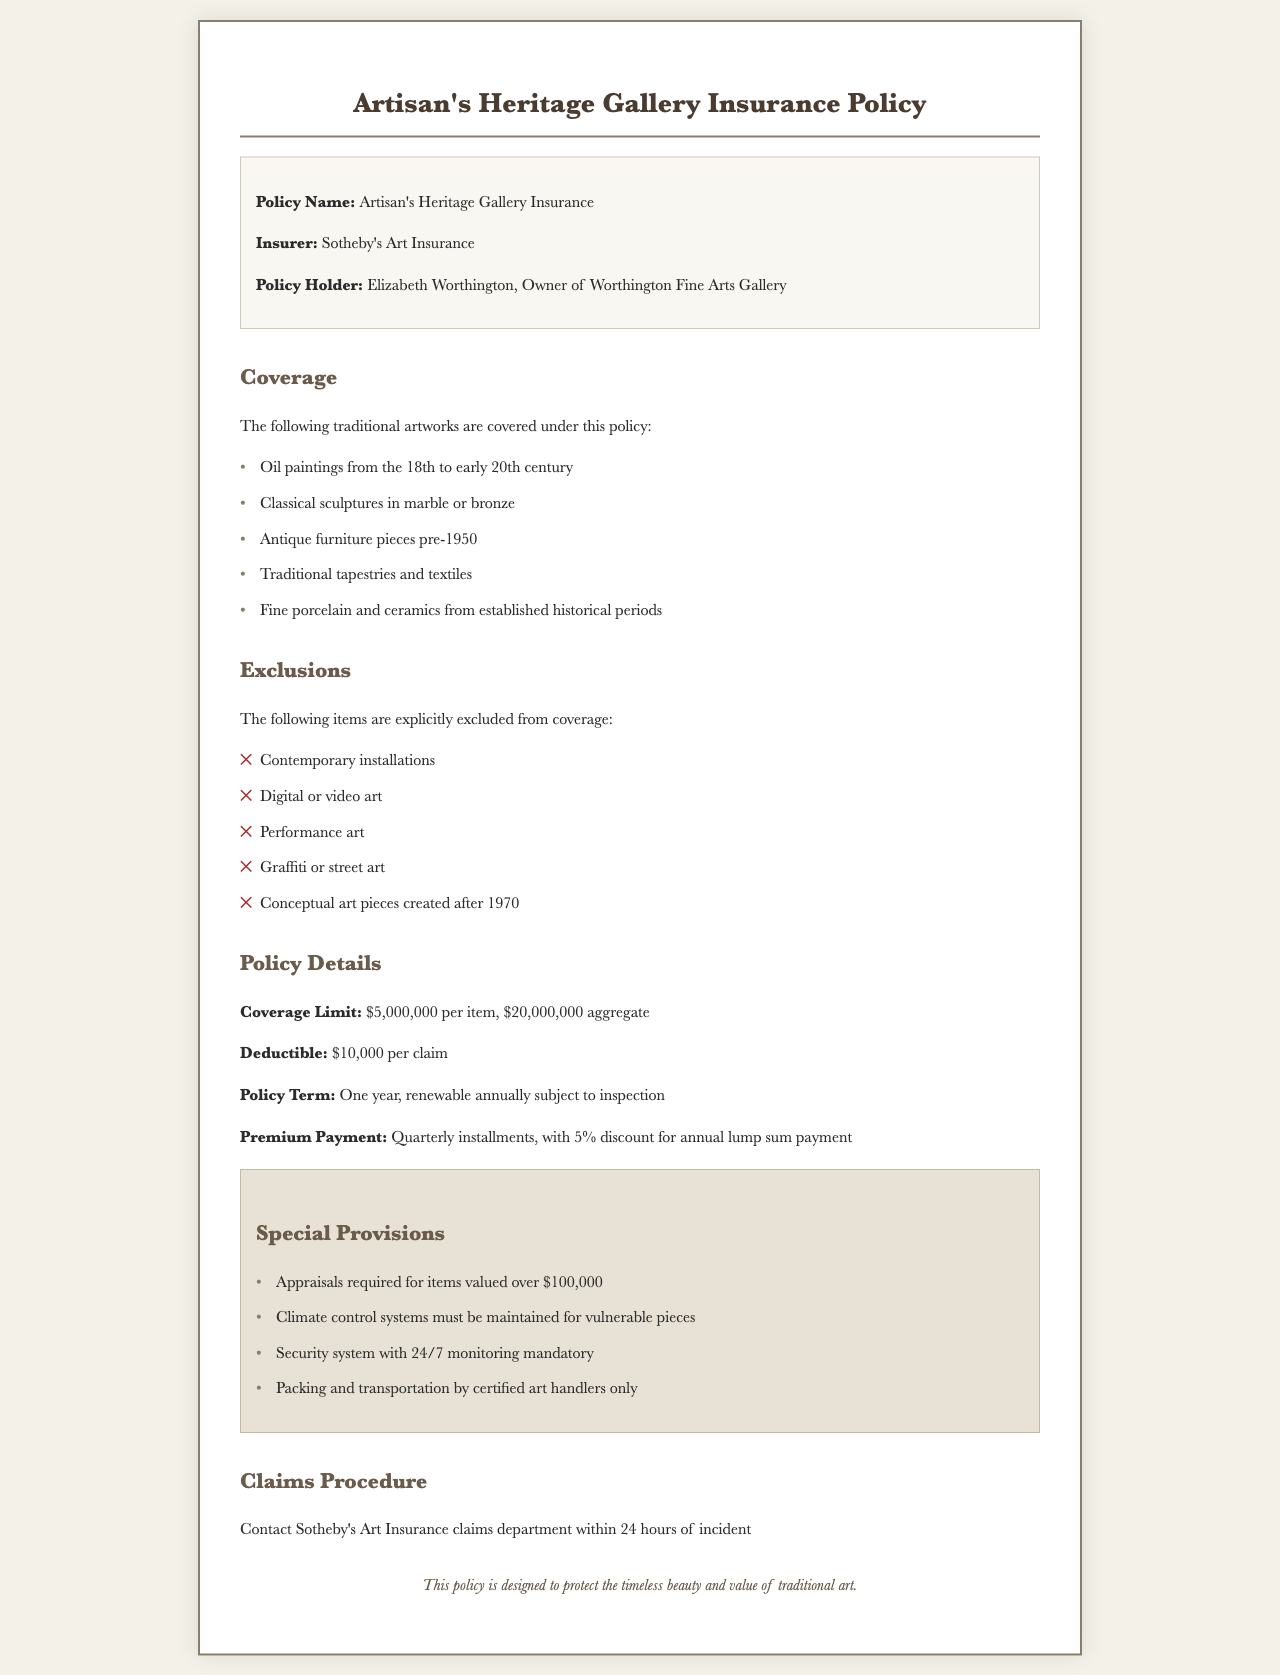What is the insurer's name? The insurer is mentioned in the policy as Sotheby's Art Insurance.
Answer: Sotheby's Art Insurance What is the policy limit for a single item? The document specifies that the coverage limit per item is $5,000,000.
Answer: $5,000,000 Which items are covered under this policy? The policy covers traditional artworks such as oil paintings from the 18th to early 20th century, classical sculptures, antique furniture, traditional tapestries, and fine porcelain.
Answer: Oil paintings, sculptures, furniture, tapestries, porcelain What is the deductible amount? The deductible amount specified in the document is $10,000 per claim.
Answer: $10,000 Which types of art are excluded from coverage? The exclusions list various modern art forms, including contemporary installations, digital art, and graffiti.
Answer: Contemporary installations, digital art, graffiti What is required for items valued over a specific amount? The document states that appraisals are required for items valued over $100,000.
Answer: $100,000 What is the policy renewal frequency? The document indicates that the policy is renewable annually.
Answer: Annually What must be maintained for vulnerable pieces? The policy requires that climate control systems be maintained for vulnerable pieces.
Answer: Climate control systems How soon must a claim be reported? The claims procedure states that claims must be reported within 24 hours of an incident.
Answer: 24 hours 